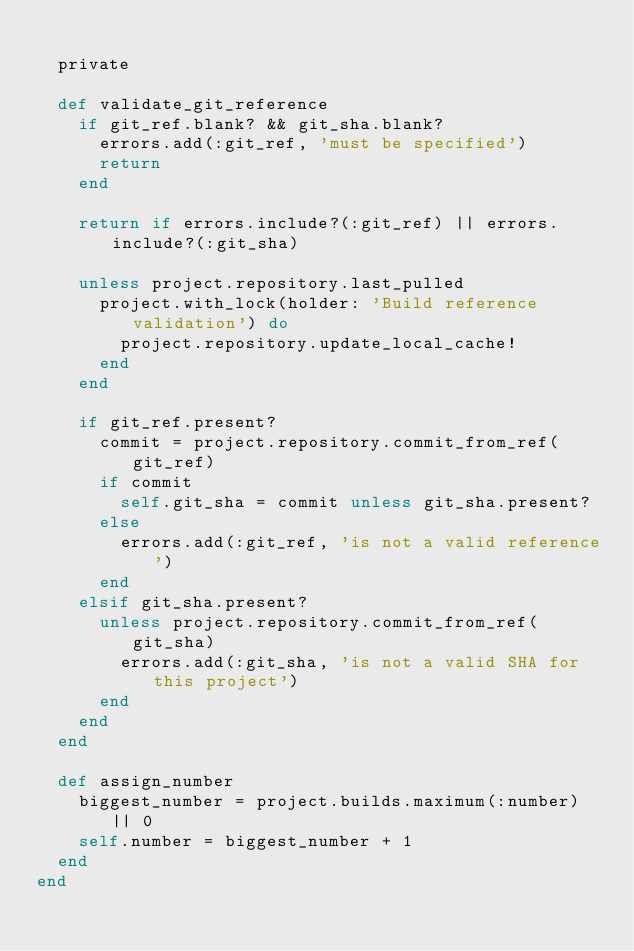Convert code to text. <code><loc_0><loc_0><loc_500><loc_500><_Ruby_>
  private

  def validate_git_reference
    if git_ref.blank? && git_sha.blank?
      errors.add(:git_ref, 'must be specified')
      return
    end

    return if errors.include?(:git_ref) || errors.include?(:git_sha)

    unless project.repository.last_pulled
      project.with_lock(holder: 'Build reference validation') do
        project.repository.update_local_cache!
      end
    end

    if git_ref.present?
      commit = project.repository.commit_from_ref(git_ref)
      if commit
        self.git_sha = commit unless git_sha.present?
      else
        errors.add(:git_ref, 'is not a valid reference')
      end
    elsif git_sha.present?
      unless project.repository.commit_from_ref(git_sha)
        errors.add(:git_sha, 'is not a valid SHA for this project')
      end
    end
  end

  def assign_number
    biggest_number = project.builds.maximum(:number) || 0
    self.number = biggest_number + 1
  end
end
</code> 